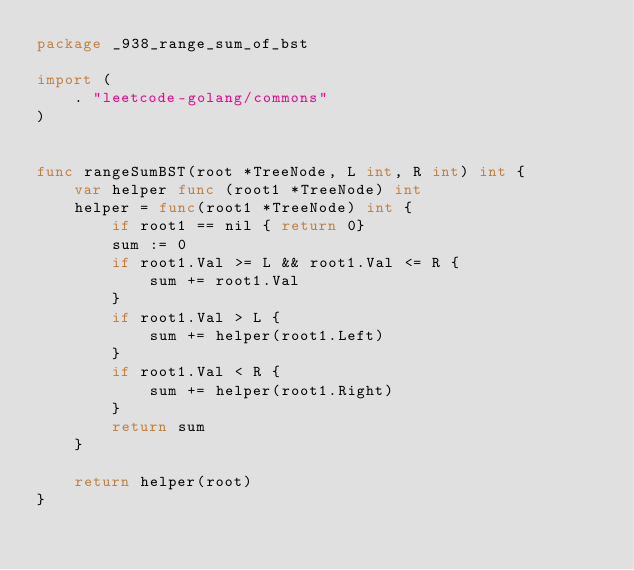Convert code to text. <code><loc_0><loc_0><loc_500><loc_500><_Go_>package _938_range_sum_of_bst

import (
	. "leetcode-golang/commons"
)


func rangeSumBST(root *TreeNode, L int, R int) int {
	var helper func (root1 *TreeNode) int
	helper = func(root1 *TreeNode) int {
		if root1 == nil { return 0}
		sum := 0
		if root1.Val >= L && root1.Val <= R {
			sum += root1.Val
		}
		if root1.Val > L {
			sum += helper(root1.Left)
		}
		if root1.Val < R {
			sum += helper(root1.Right)
		}
		return sum
	}

	return helper(root)
}</code> 